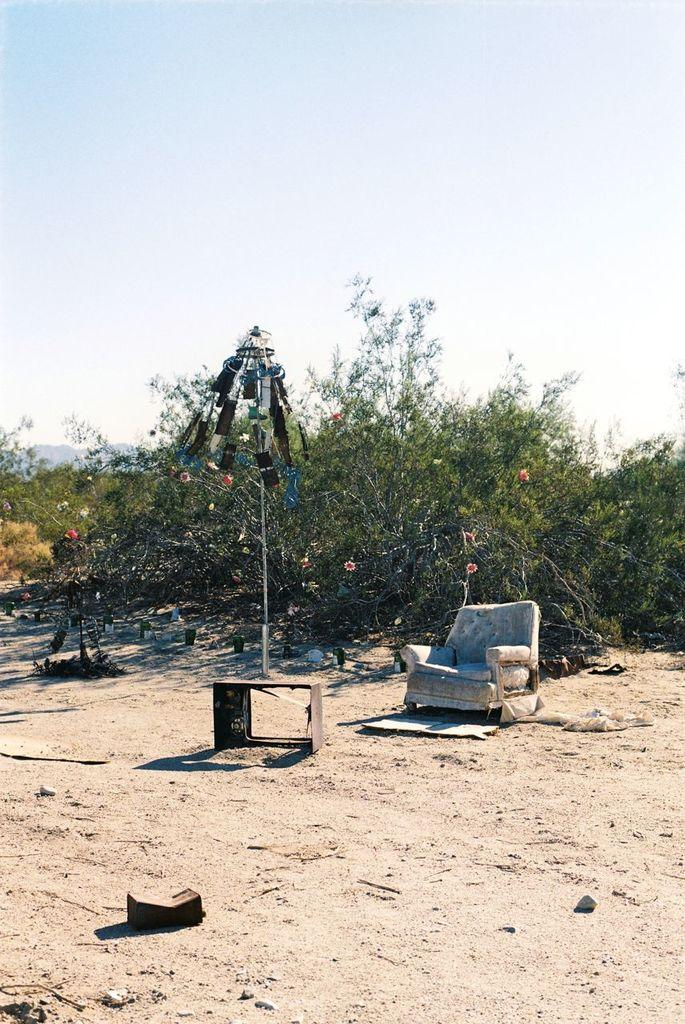What type of furniture is present in the image? There is a chair in the image. What else can be seen on the ground in the image? There are objects on the ground in the image. What is visible in the background of the image? Planets and the sky are visible in the background of the image. What type of lunch is the sister eating in the image? There is no sister or lunch present in the image. How many teeth can be seen in the mouth of the person in the image? There is no person or mouth visible in the image. 